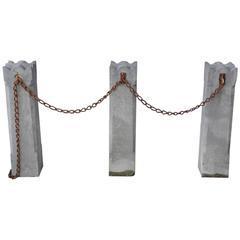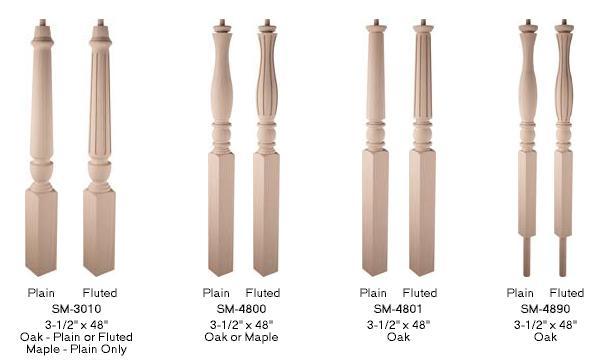The first image is the image on the left, the second image is the image on the right. Analyze the images presented: Is the assertion "In at least one image one of the row have seven  wooden rails." valid? Answer yes or no. No. The first image is the image on the left, the second image is the image on the right. Evaluate the accuracy of this statement regarding the images: "Each image contains at least one row of beige posts displayed vertically with space between each one.". Is it true? Answer yes or no. No. 